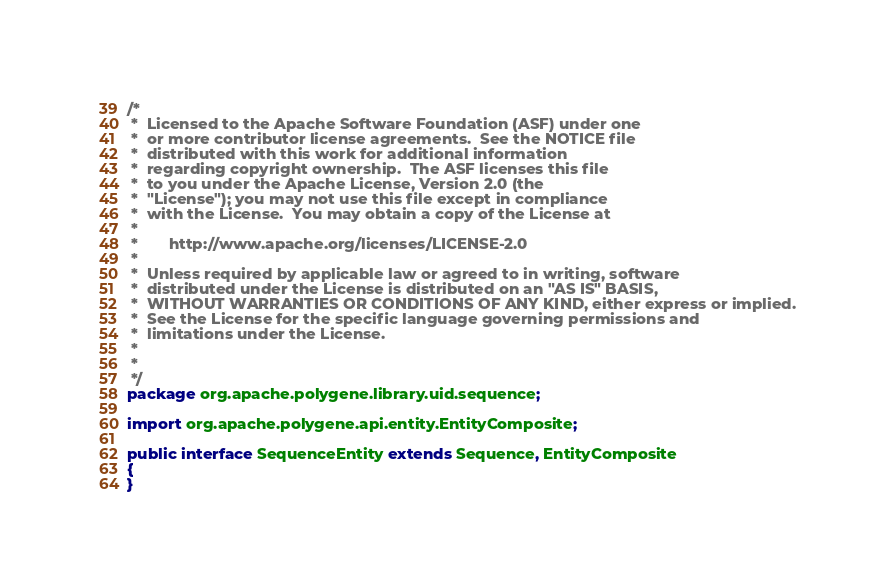<code> <loc_0><loc_0><loc_500><loc_500><_Java_>/*
 *  Licensed to the Apache Software Foundation (ASF) under one
 *  or more contributor license agreements.  See the NOTICE file
 *  distributed with this work for additional information
 *  regarding copyright ownership.  The ASF licenses this file
 *  to you under the Apache License, Version 2.0 (the
 *  "License"); you may not use this file except in compliance
 *  with the License.  You may obtain a copy of the License at
 *
 *       http://www.apache.org/licenses/LICENSE-2.0
 *
 *  Unless required by applicable law or agreed to in writing, software
 *  distributed under the License is distributed on an "AS IS" BASIS,
 *  WITHOUT WARRANTIES OR CONDITIONS OF ANY KIND, either express or implied.
 *  See the License for the specific language governing permissions and
 *  limitations under the License.
 *
 *
 */
package org.apache.polygene.library.uid.sequence;

import org.apache.polygene.api.entity.EntityComposite;

public interface SequenceEntity extends Sequence, EntityComposite
{
}
</code> 